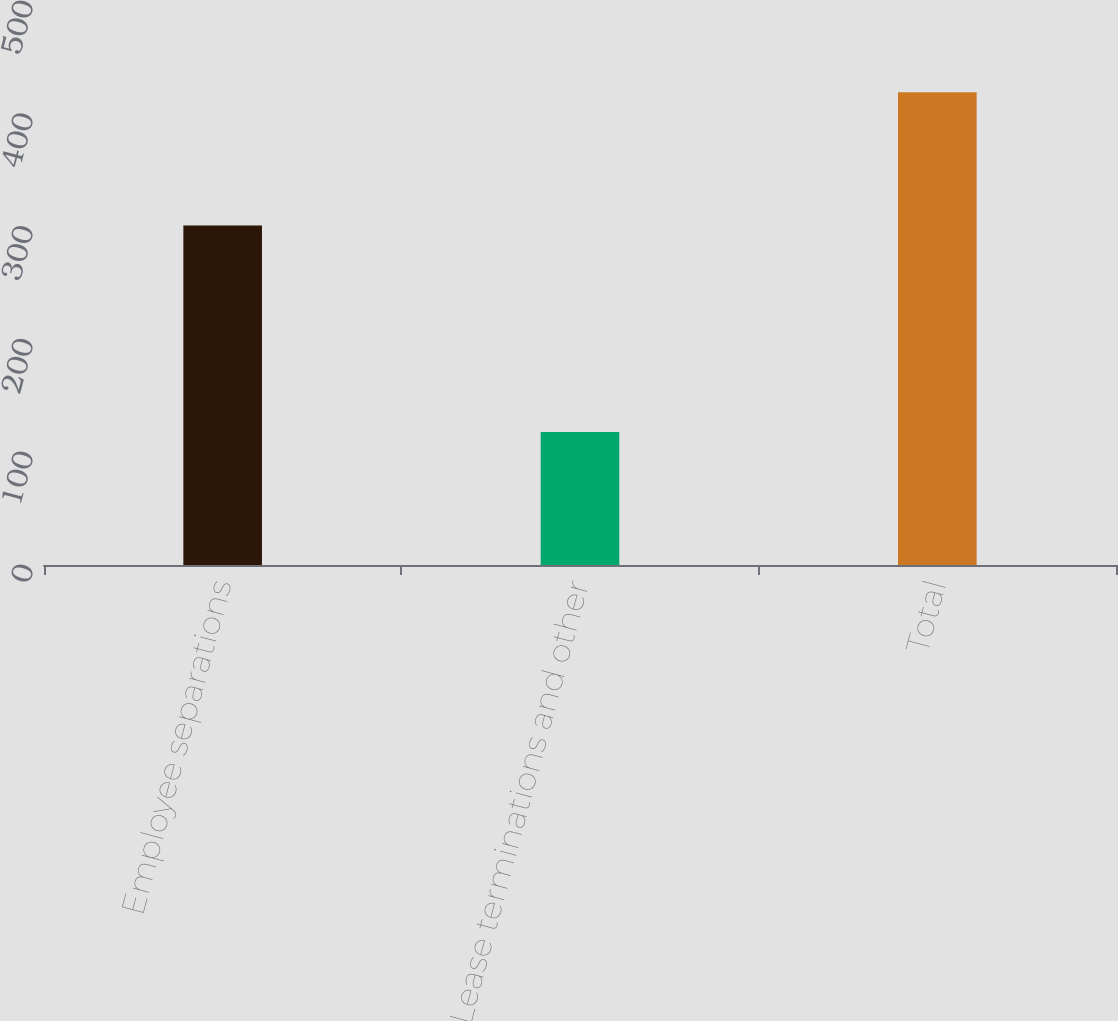Convert chart. <chart><loc_0><loc_0><loc_500><loc_500><bar_chart><fcel>Employee separations<fcel>Lease terminations and other<fcel>Total<nl><fcel>301<fcel>118<fcel>419<nl></chart> 